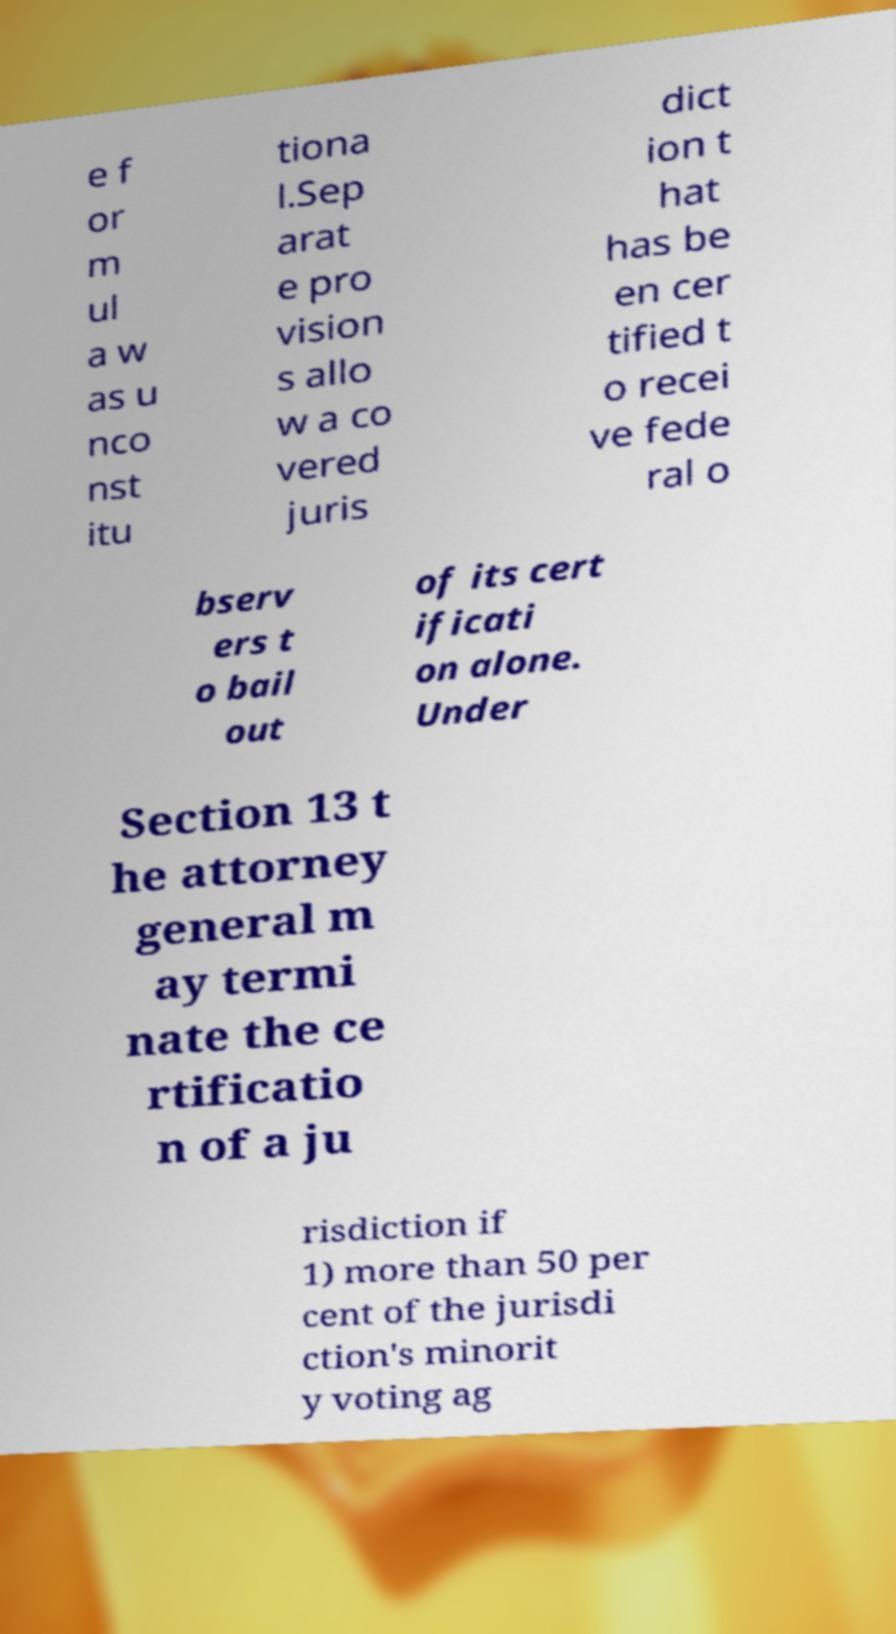There's text embedded in this image that I need extracted. Can you transcribe it verbatim? e f or m ul a w as u nco nst itu tiona l.Sep arat e pro vision s allo w a co vered juris dict ion t hat has be en cer tified t o recei ve fede ral o bserv ers t o bail out of its cert ificati on alone. Under Section 13 t he attorney general m ay termi nate the ce rtificatio n of a ju risdiction if 1) more than 50 per cent of the jurisdi ction's minorit y voting ag 